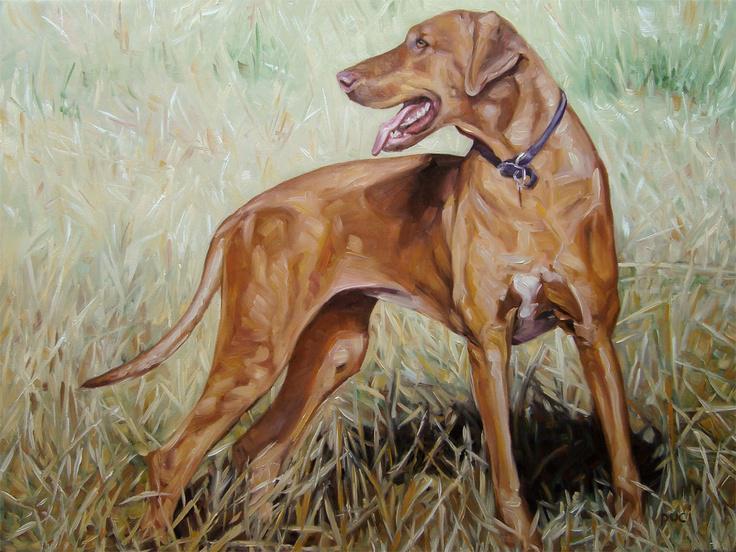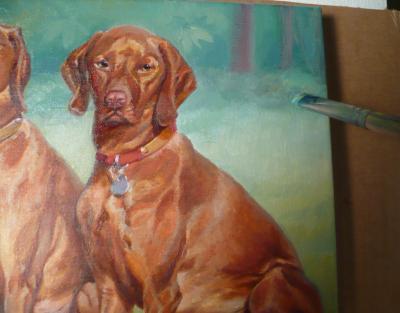The first image is the image on the left, the second image is the image on the right. Evaluate the accuracy of this statement regarding the images: "The left image features a dog with its head turned to the left, and the right image features a dog sitting upright, gazing straight ahead, and wearing a collar with a tag dangling from it.". Is it true? Answer yes or no. Yes. The first image is the image on the left, the second image is the image on the right. Considering the images on both sides, is "The dog on the left is looking left and the dog on the right is looking straight ahead." valid? Answer yes or no. Yes. 